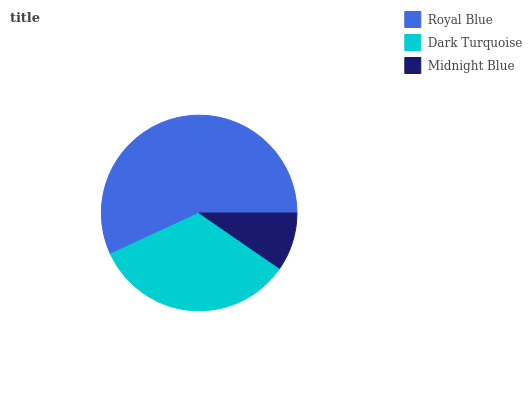Is Midnight Blue the minimum?
Answer yes or no. Yes. Is Royal Blue the maximum?
Answer yes or no. Yes. Is Dark Turquoise the minimum?
Answer yes or no. No. Is Dark Turquoise the maximum?
Answer yes or no. No. Is Royal Blue greater than Dark Turquoise?
Answer yes or no. Yes. Is Dark Turquoise less than Royal Blue?
Answer yes or no. Yes. Is Dark Turquoise greater than Royal Blue?
Answer yes or no. No. Is Royal Blue less than Dark Turquoise?
Answer yes or no. No. Is Dark Turquoise the high median?
Answer yes or no. Yes. Is Dark Turquoise the low median?
Answer yes or no. Yes. Is Royal Blue the high median?
Answer yes or no. No. Is Royal Blue the low median?
Answer yes or no. No. 